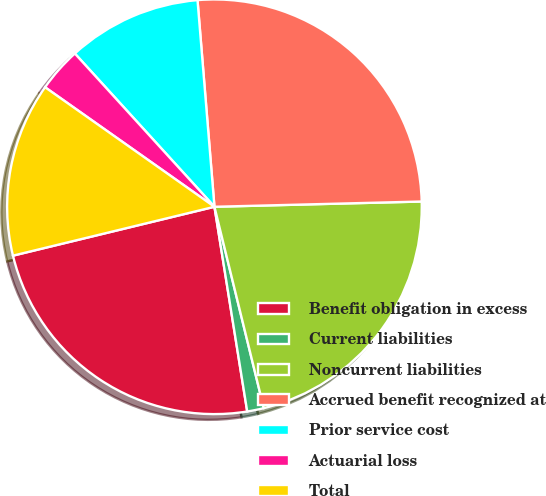<chart> <loc_0><loc_0><loc_500><loc_500><pie_chart><fcel>Benefit obligation in excess<fcel>Current liabilities<fcel>Noncurrent liabilities<fcel>Accrued benefit recognized at<fcel>Prior service cost<fcel>Actuarial loss<fcel>Total<nl><fcel>23.74%<fcel>1.3%<fcel>21.58%<fcel>25.9%<fcel>10.46%<fcel>3.46%<fcel>13.57%<nl></chart> 